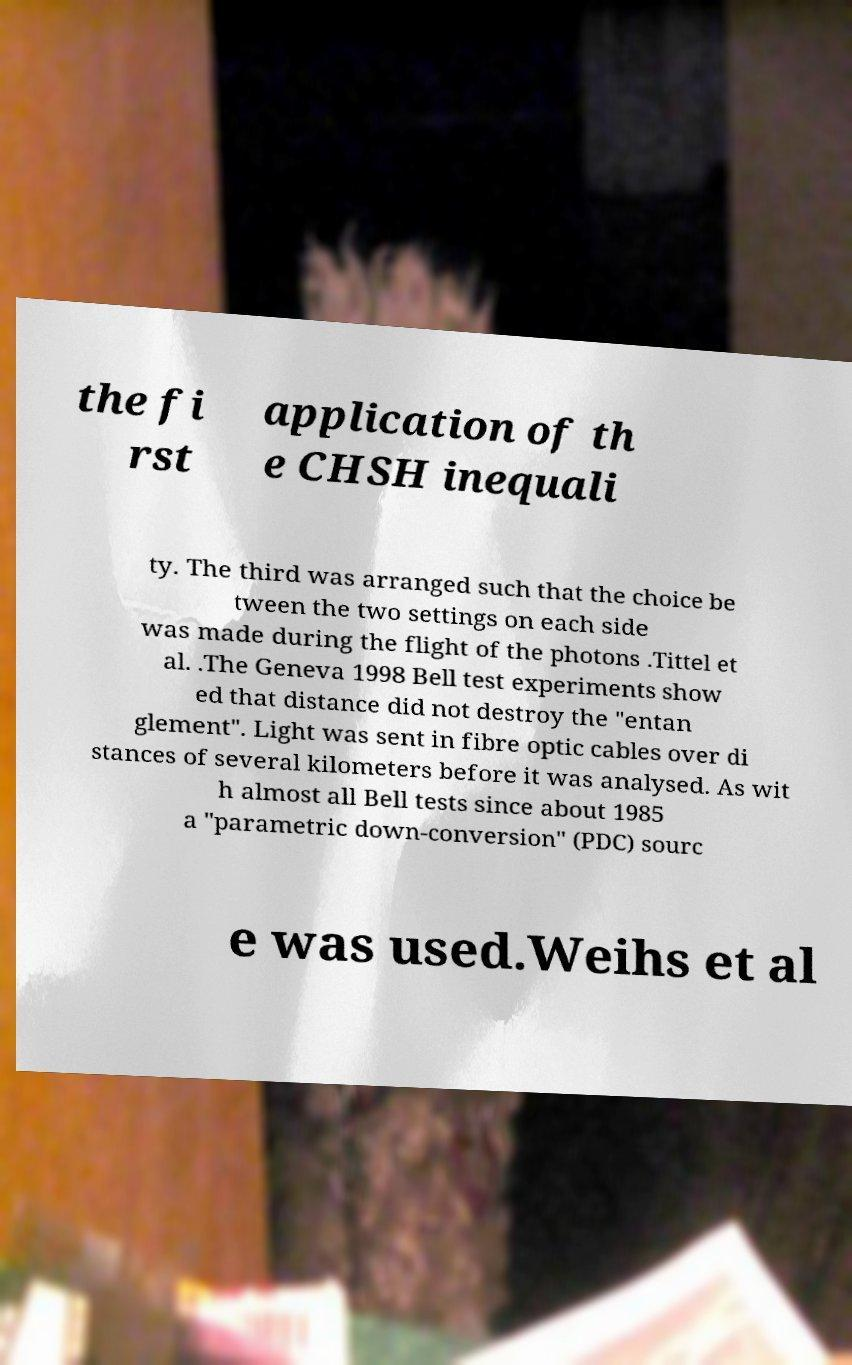Can you read and provide the text displayed in the image?This photo seems to have some interesting text. Can you extract and type it out for me? the fi rst application of th e CHSH inequali ty. The third was arranged such that the choice be tween the two settings on each side was made during the flight of the photons .Tittel et al. .The Geneva 1998 Bell test experiments show ed that distance did not destroy the "entan glement". Light was sent in fibre optic cables over di stances of several kilometers before it was analysed. As wit h almost all Bell tests since about 1985 a "parametric down-conversion" (PDC) sourc e was used.Weihs et al 